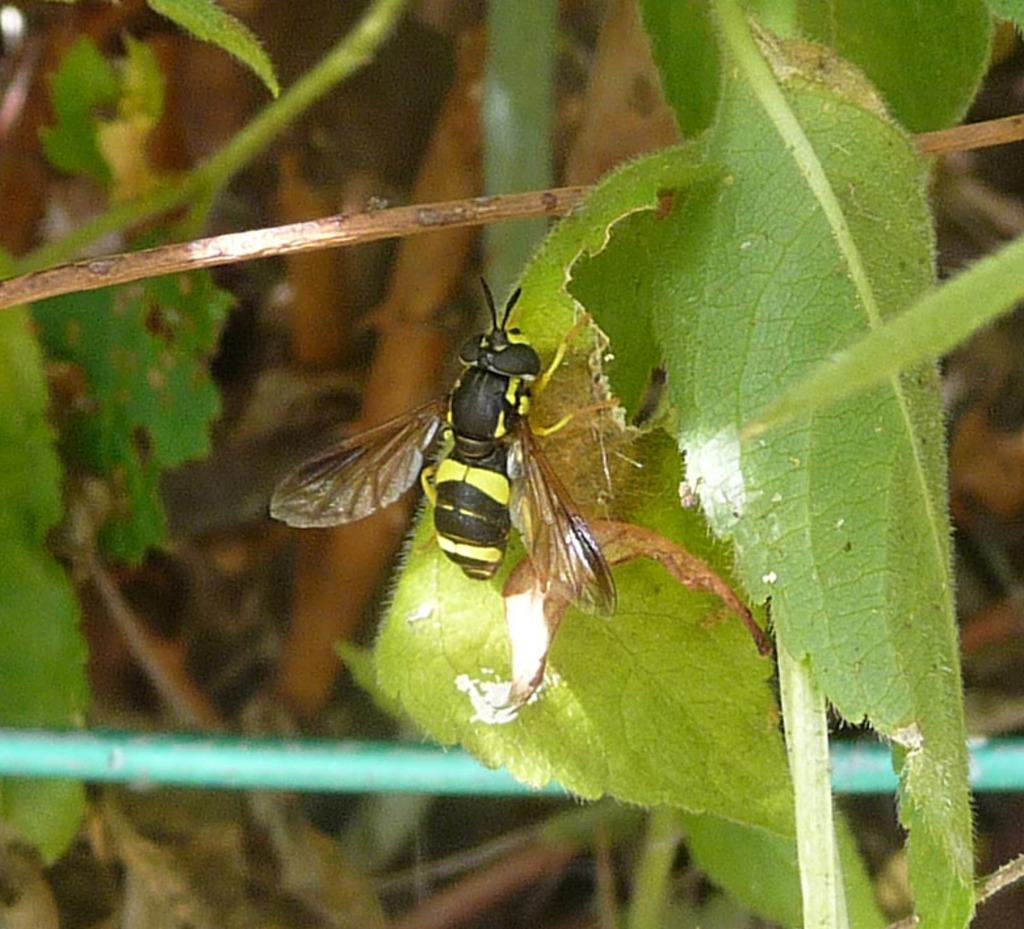What is on the leaf in the image? There is an insect on a leaf in the image. What is the leaf a part of? The leaf is part of a plant. What can be seen in the background of the image? There are leaves visible in the background of the image. What type of pie is being served at the battle in the image? There is no pie or battle present in the image; it features an insect on a leaf. 